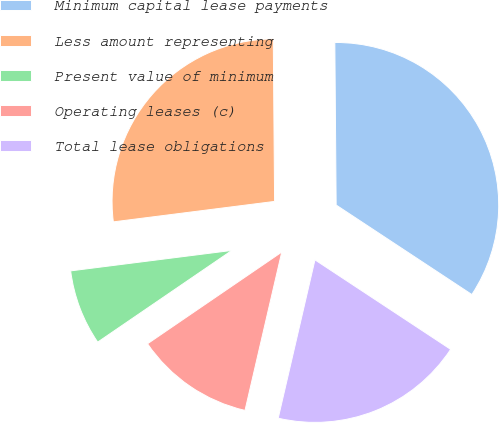<chart> <loc_0><loc_0><loc_500><loc_500><pie_chart><fcel>Minimum capital lease payments<fcel>Less amount representing<fcel>Present value of minimum<fcel>Operating leases (c)<fcel>Total lease obligations<nl><fcel>34.41%<fcel>26.88%<fcel>7.53%<fcel>11.83%<fcel>19.35%<nl></chart> 